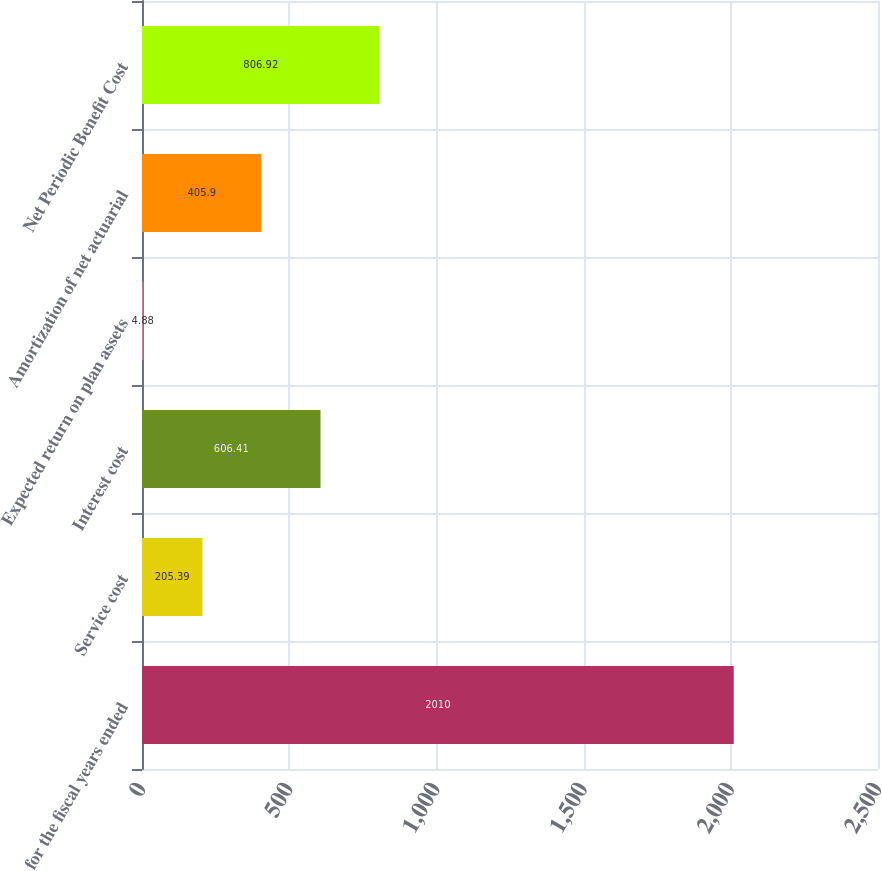Convert chart to OTSL. <chart><loc_0><loc_0><loc_500><loc_500><bar_chart><fcel>for the fiscal years ended<fcel>Service cost<fcel>Interest cost<fcel>Expected return on plan assets<fcel>Amortization of net actuarial<fcel>Net Periodic Benefit Cost<nl><fcel>2010<fcel>205.39<fcel>606.41<fcel>4.88<fcel>405.9<fcel>806.92<nl></chart> 